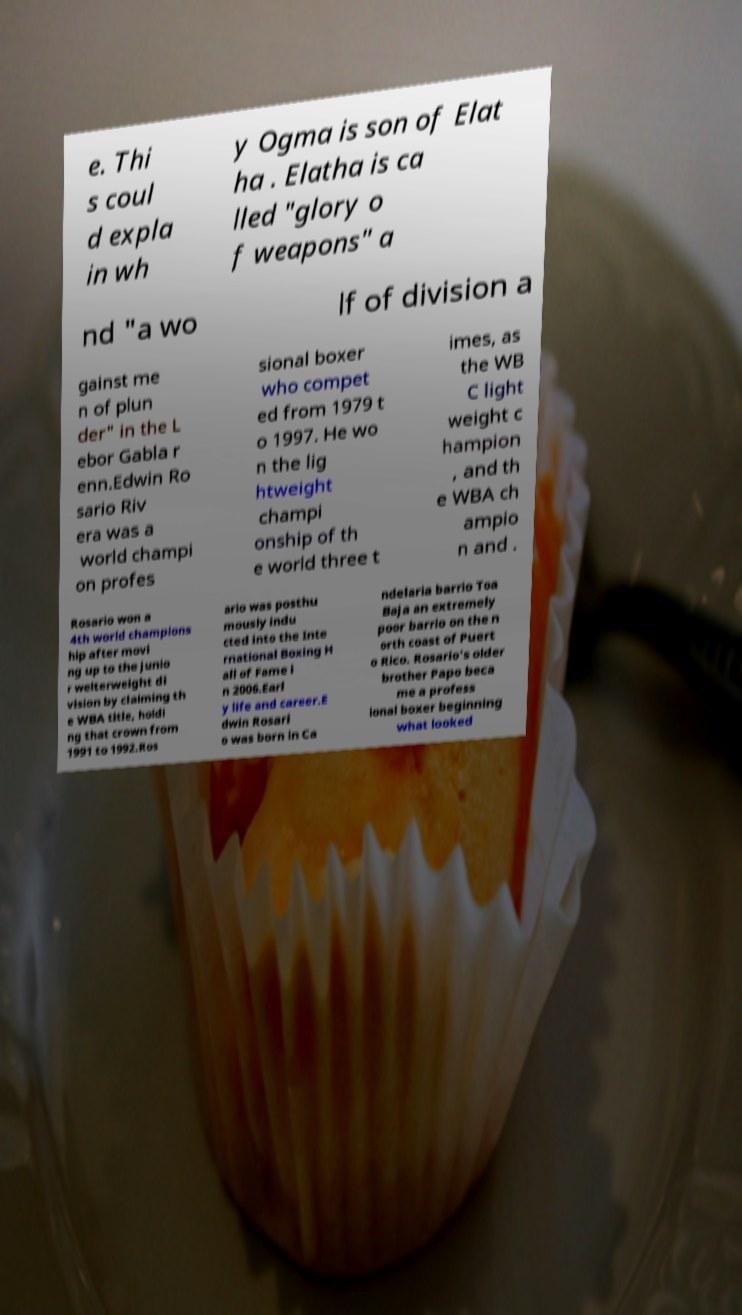There's text embedded in this image that I need extracted. Can you transcribe it verbatim? e. Thi s coul d expla in wh y Ogma is son of Elat ha . Elatha is ca lled "glory o f weapons" a nd "a wo lf of division a gainst me n of plun der" in the L ebor Gabla r enn.Edwin Ro sario Riv era was a world champi on profes sional boxer who compet ed from 1979 t o 1997. He wo n the lig htweight champi onship of th e world three t imes, as the WB C light weight c hampion , and th e WBA ch ampio n and . Rosario won a 4th world champions hip after movi ng up to the junio r welterweight di vision by claiming th e WBA title, holdi ng that crown from 1991 to 1992.Ros ario was posthu mously indu cted into the Inte rnational Boxing H all of Fame i n 2006.Earl y life and career.E dwin Rosari o was born in Ca ndelaria barrio Toa Baja an extremely poor barrio on the n orth coast of Puert o Rico. Rosario's older brother Papo beca me a profess ional boxer beginning what looked 